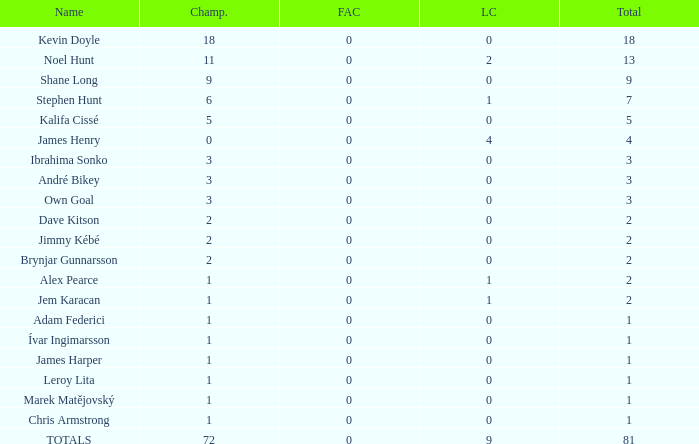What is the total championships that the league cup is less than 0? None. 